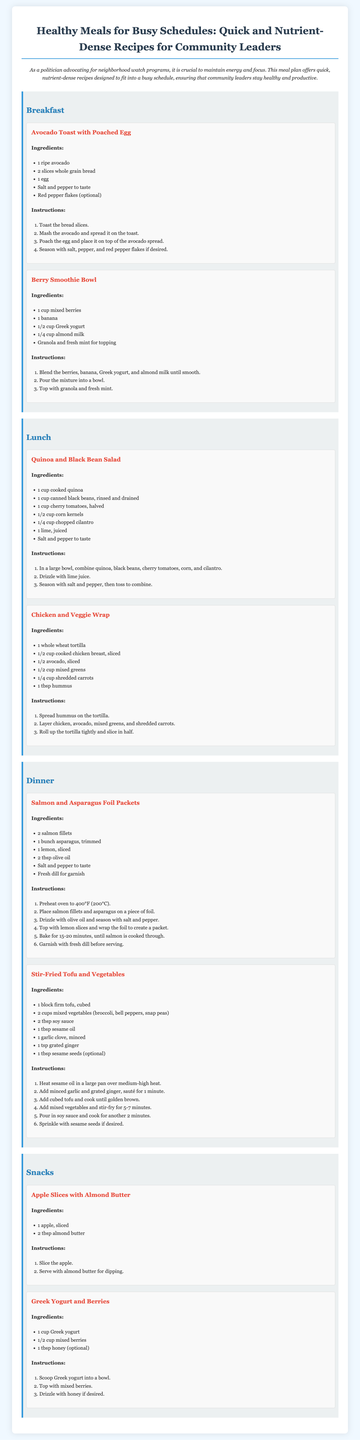What is the title of the meal plan? The title of the document outlines the focus on healthy meals suitable for busy leaders, specifically designed for community leaders.
Answer: Healthy Meals for Busy Schedules: Quick and Nutrient-Dense Recipes for Community Leaders What is the first breakfast recipe listed? The first breakfast recipe provides details on how to prepare a healthy meal to start the day, emphasizing quick preparation.
Answer: Avocado Toast with Poached Egg How many lunch recipes are included in the document? The document lists a total of two recipes under the lunch section, each providing quick and healthy options.
Answer: 2 What ingredient is common in both dinner recipes? The dinner recipes highlight a variety of ingredients; a specific common ingredient can help in meal planning and preparation.
Answer: None (no common ingredient) What type of meal is "Quinoa and Black Bean Salad"? The classification of this dish provides insight into which part of the day it is meant to be consumed, fitting the lifestyle of busy leaders.
Answer: Lunch How long should the salmon and asparagus foil packets be baked? This detail is essential for preparation time, providing guidance on how to efficiently manage cooking while maintaining an active schedule.
Answer: 15-20 minutes What is used for topping the berry smoothie bowl? This additional information highlights a way to enhance the dish's flavor and presentation, appealing to busy schedules requiring quick assembly.
Answer: Granola and fresh mint What is the main protein source in the dinner recipe "Stir-Fried Tofu and Vegetables"? Identifying the primary protein source in this dish is key for those seeking vegetarian options within their meal plan.
Answer: Tofu 